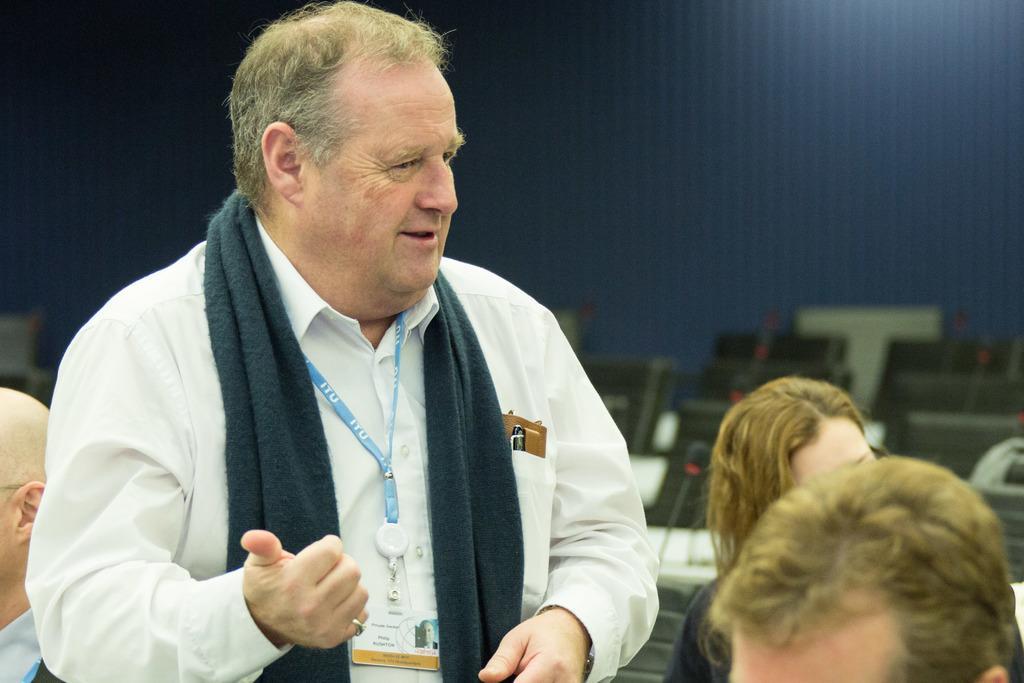In one or two sentences, can you explain what this image depicts? In this image we can see some persons. In the background of the image there is a wall, chairs and other objects. 